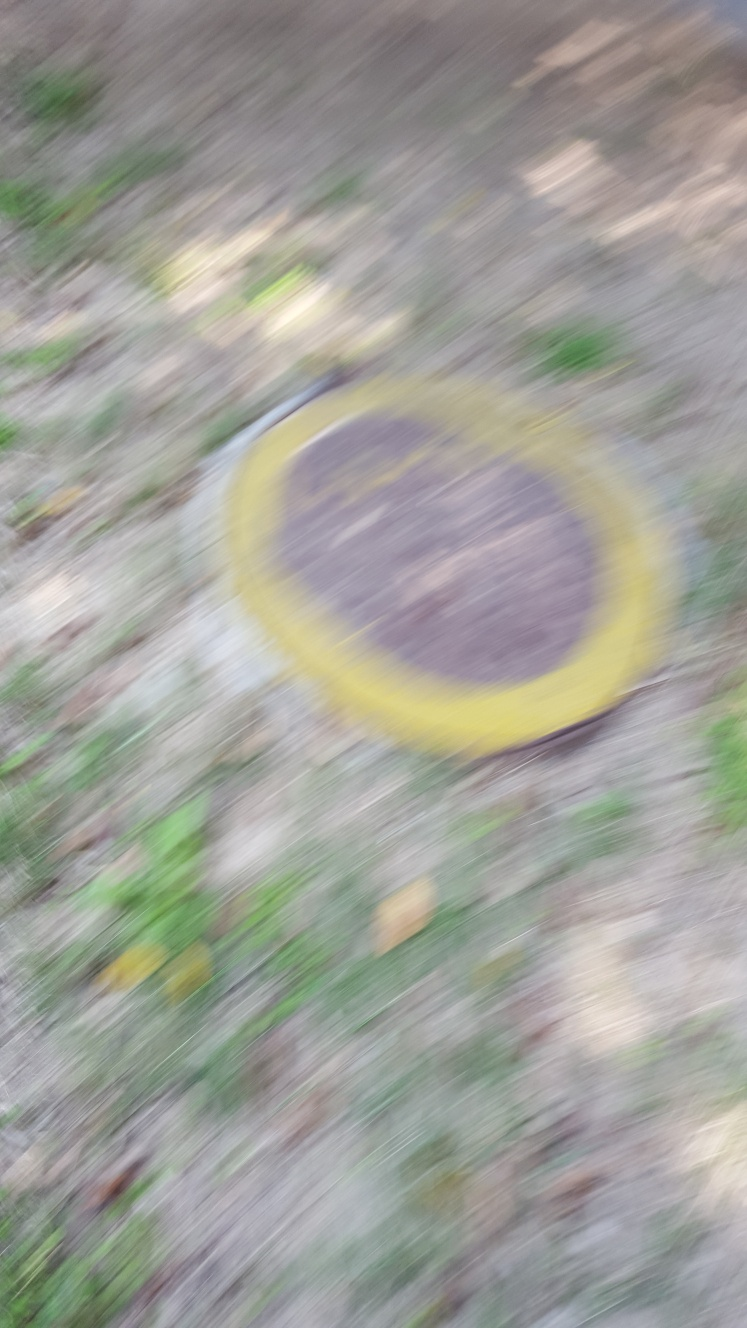What time of day do you think it is in the photo? It's challenging to determine the exact time of day due to the blurriness. However, the overall brightness and the presence of shadows hint at it possibly being daytime. Without clearer indications of the position of the sun or the intensity of the light, it's difficult to be more specific. 